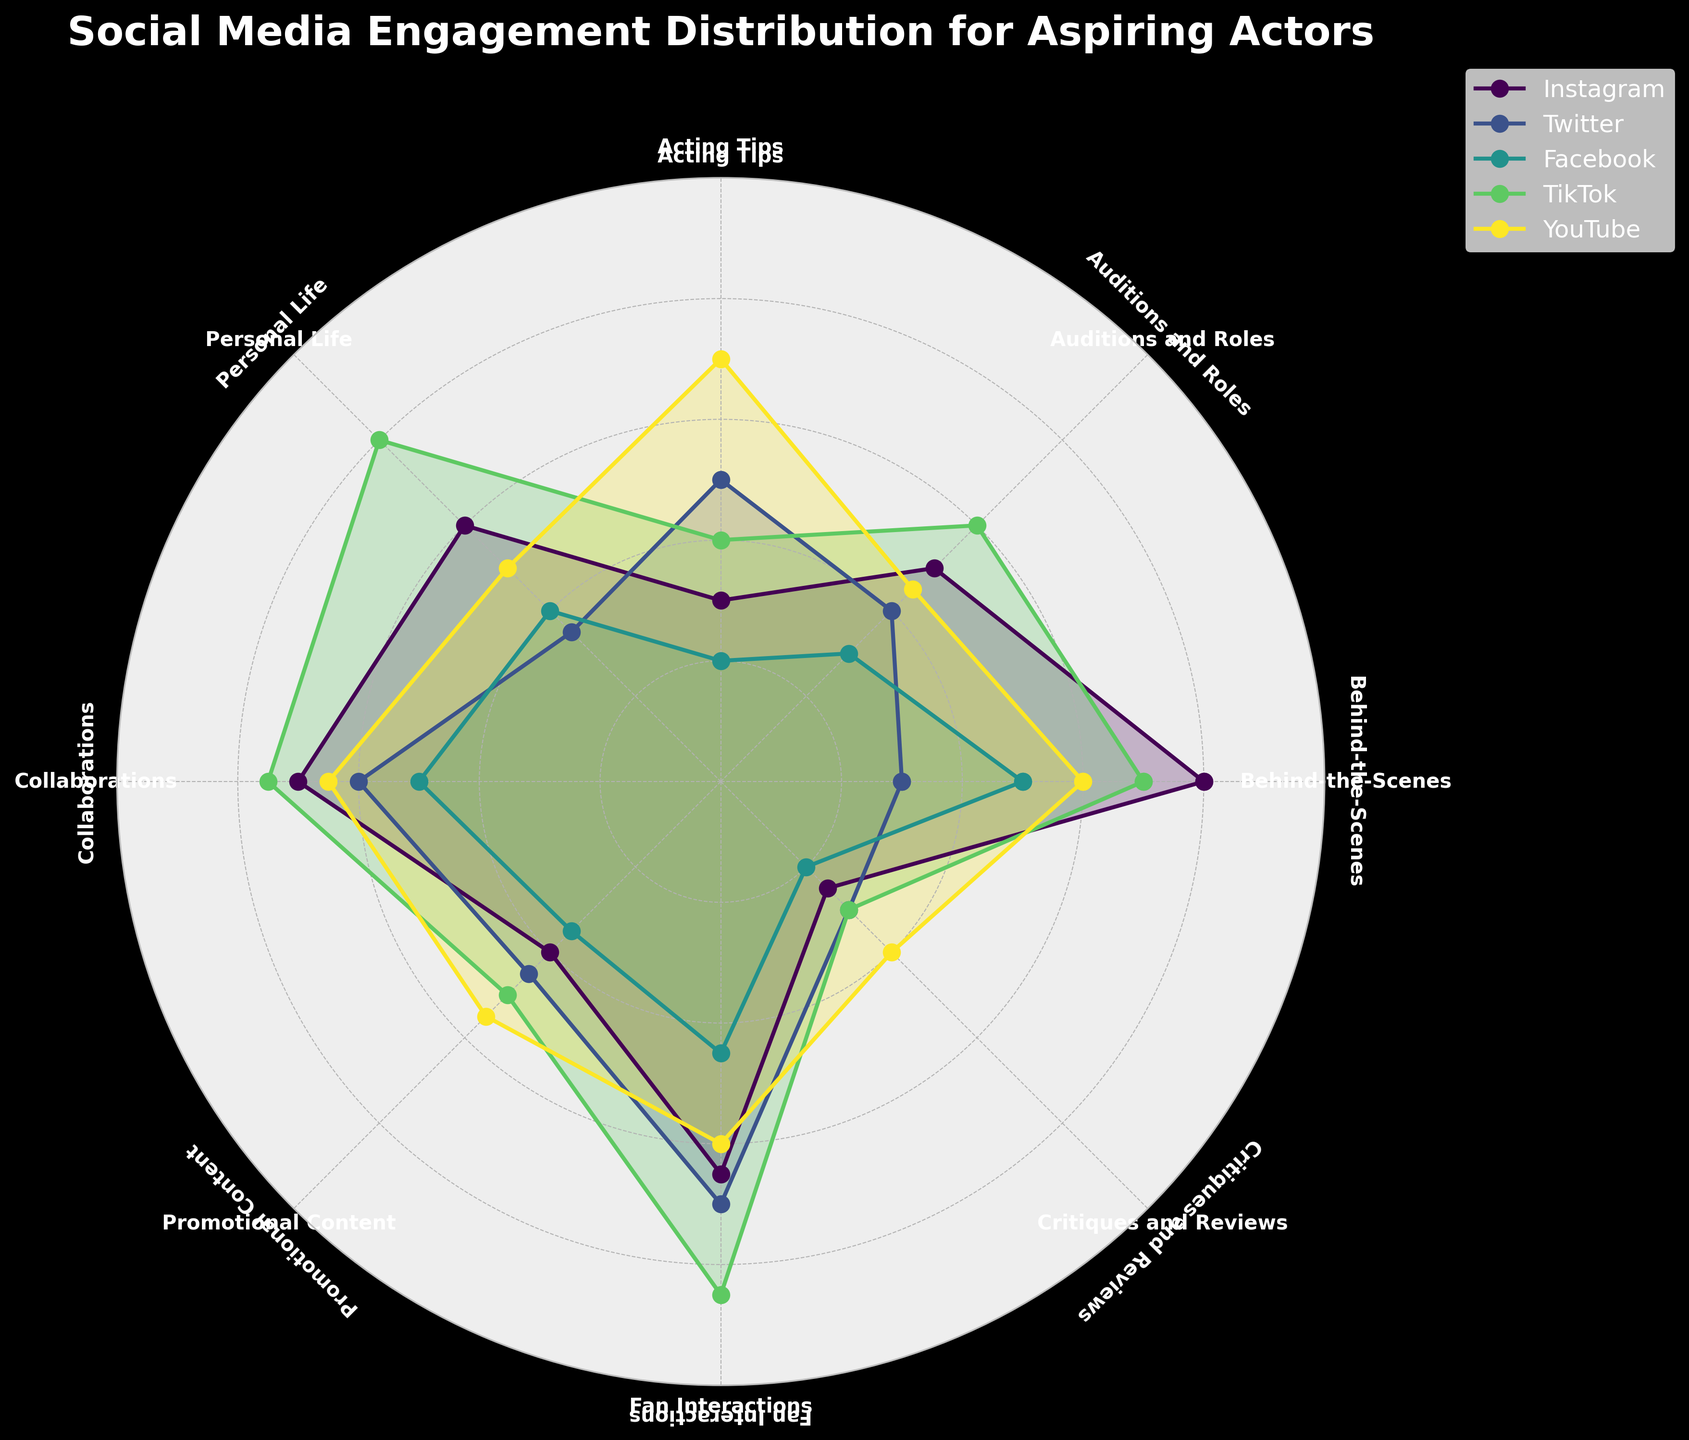What is the title of the figure? The title of the chart is typically prominently placed at the top center, and it summarizes the overall focus of the plot. In this case, the title should mention the distribution of social media engagements.
Answer: Social Media Engagement Distribution for Aspiring Actors Which social media platform has the highest engagement for 'Fan Interactions'? First, identify the 'Fan Interactions' category. Then, locate its corresponding values on different social media platforms and determine which one has the highest value.
Answer: TikTok What is the average engagement across all platforms for 'Promotional Content'? First, locate the engagement values for 'Promotional Content' on all five platforms. Sum these values: 400 + 450 + 350 + 500 + 550 = 2250. Divide this sum by the number of platforms, which is 5.
Answer: 450 Which category has the lowest engagement for YouTube? For each category, find the engagement values associated with YouTube. Identify the category with the lowest value among these.
Answer: Critiques and Reviews Is engagement higher for 'Behind-the-Scenes' or 'Auditions and Roles' on Instagram? Compare the engagement values for 'Behind-the-Scenes' and 'Auditions and Roles' on Instagram only. Identify which is greater: 800 (Behind-the-Scenes) vs. 500 (Auditions and Roles).
Answer: Behind-the-Scenes Which category shows the most balanced engagement across all platforms? For this, observe each category's engagements across the five platforms and assess which one has values closest to one another. 'Collaborations' with values 700, 600, 500, 750, and 650 seems balanced.
Answer: Collaborations What is the total engagement across all categories for Facebook? Sum up the engagement values for all categories on Facebook. 500 + 300 + 200 + 400 + 500 + 350 + 450 + 200 = 2900
Answer: 2900 How does 'Personal Life' engagement on TikTok compare with 'Acting Tips' engagement on YouTube? Compare the engagement value on TikTok for 'Personal Life' (800) with 'Acting Tips' on YouTube (700) to see which is higher.
Answer: Personal Life higher on TikTok For which category is Twitter engagement higher than Facebook engagement? For each category, compare values between Twitter and Facebook. Identify cases where Twitter's figure surpasses Facebook's.
Answer: Auditions and Roles Which platform has the most overall engagement across all categories? Compute the sum of engagements across all categories for each platform and compare these sums. This involves adding up the vertical sums in the data table.
Answer: TikTok 